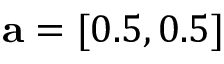<formula> <loc_0><loc_0><loc_500><loc_500>a = [ 0 . 5 , 0 . 5 ]</formula> 